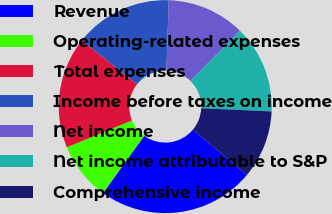Convert chart. <chart><loc_0><loc_0><loc_500><loc_500><pie_chart><fcel>Revenue<fcel>Operating-related expenses<fcel>Total expenses<fcel>Income before taxes on income<fcel>Net income<fcel>Net income attributable to S&P<fcel>Comprehensive income<nl><fcel>23.87%<fcel>8.83%<fcel>16.91%<fcel>14.85%<fcel>11.85%<fcel>13.35%<fcel>10.34%<nl></chart> 